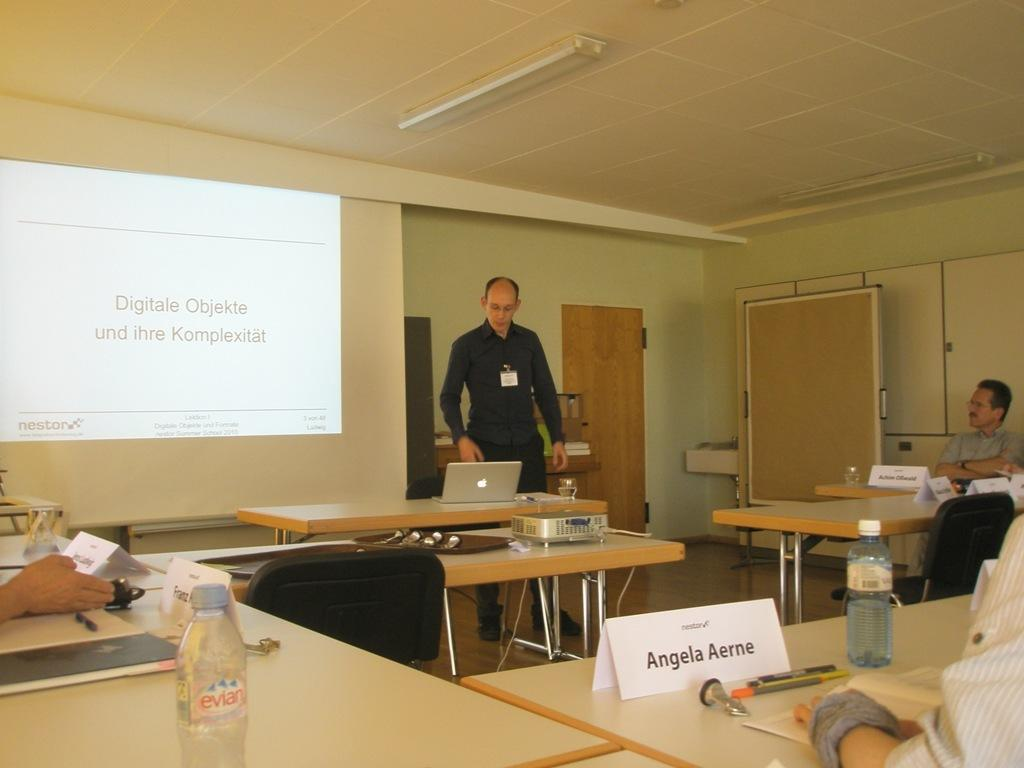Where was the image taken? The image was taken in a room. What can be seen on one of the walls in the room? There is a screen in the room. What type of lighting is present in the room? There is a light on the top of the room. How many tables are in the room? There are multiple tables in the room. What objects can be found on the tables? There is a bottle, a laptop, a name board, and pens on one of the tables. What type of jewel is placed on the laptop in the image? There is no jewel present on the laptop in the image. Who is the friend sitting next to the person using the laptop in the image? There is no person using the laptop in the image, nor is there a friend present. 